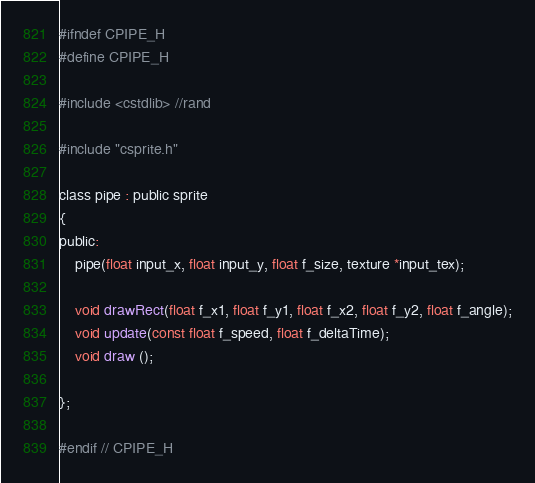Convert code to text. <code><loc_0><loc_0><loc_500><loc_500><_C_>#ifndef CPIPE_H
#define CPIPE_H

#include <cstdlib> //rand

#include "csprite.h"

class pipe : public sprite
{
public:
    pipe(float input_x, float input_y, float f_size, texture *input_tex);

    void drawRect(float f_x1, float f_y1, float f_x2, float f_y2, float f_angle);
    void update(const float f_speed, float f_deltaTime);
    void draw ();

};

#endif // CPIPE_H
</code> 